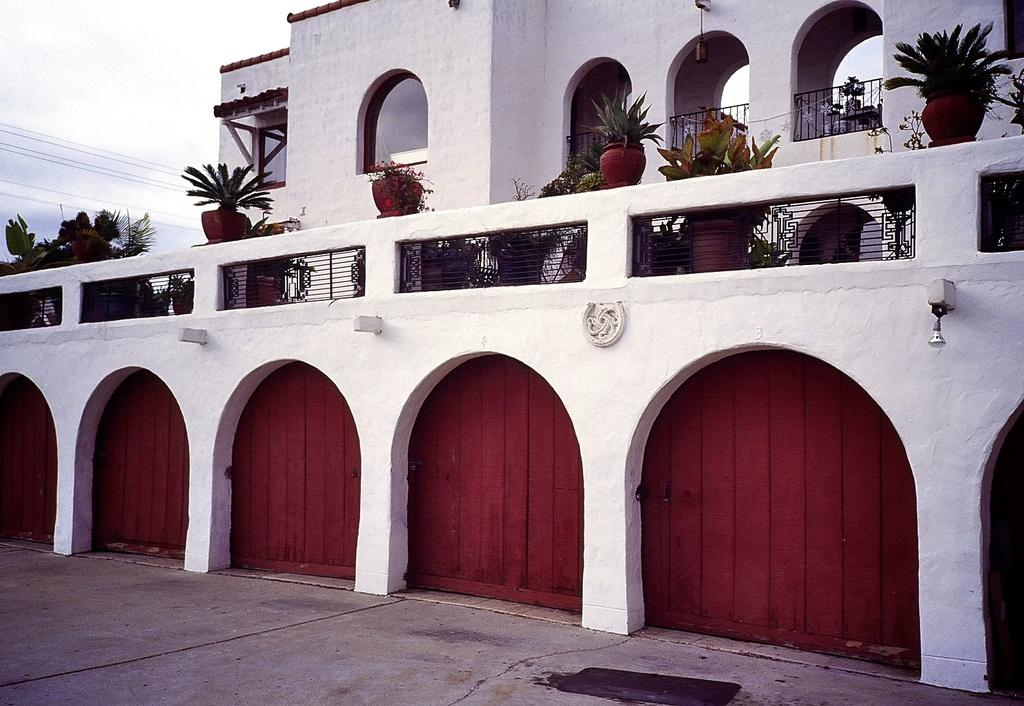What is the main subject in the center of the image? There is a building in the center of the image. What can be seen at the top side of the image? There are plants at the top side of the image. What color is the ink on the bed in the image? There is no bed or ink present in the image. How many beads are visible on the plants in the image? There are no beads present on the plants in the image. 